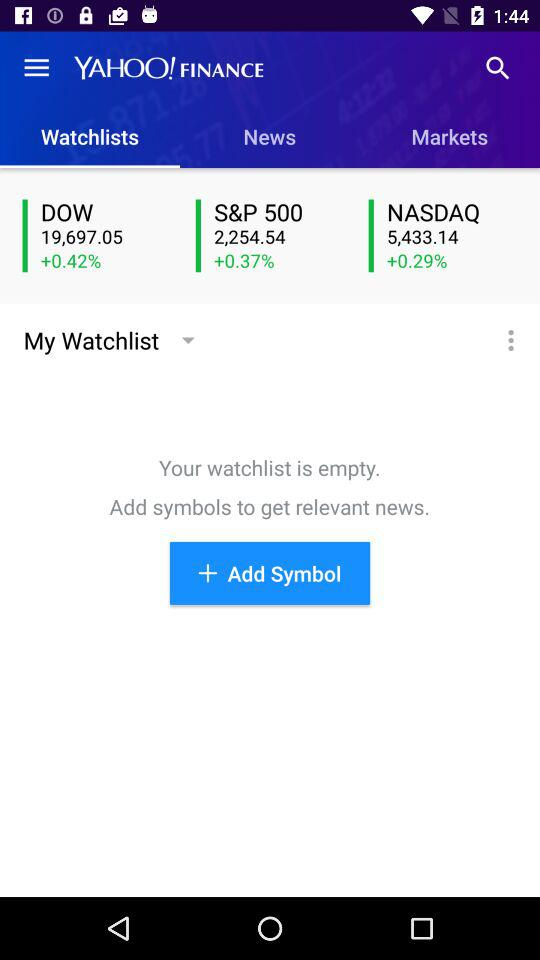Which tab is selected? The selected tab is "Watchlists". 